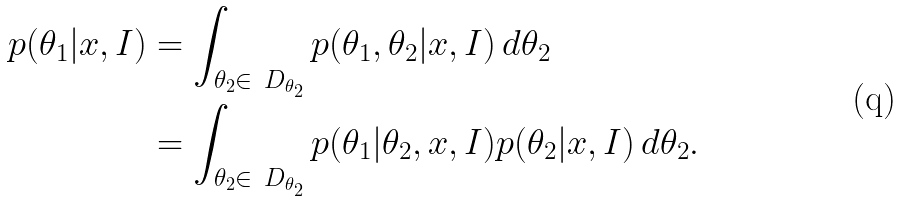Convert formula to latex. <formula><loc_0><loc_0><loc_500><loc_500>p ( \theta _ { 1 } | x , I ) & = \int _ { \theta _ { 2 } \in \ D _ { \theta _ { 2 } } } p ( \theta _ { 1 } , \theta _ { 2 } | x , I ) \, d \theta _ { 2 } \\ & = \int _ { \theta _ { 2 } \in \ D _ { \theta _ { 2 } } } p ( \theta _ { 1 } | \theta _ { 2 } , x , I ) p ( \theta _ { 2 } | x , I ) \, d \theta _ { 2 } .</formula> 